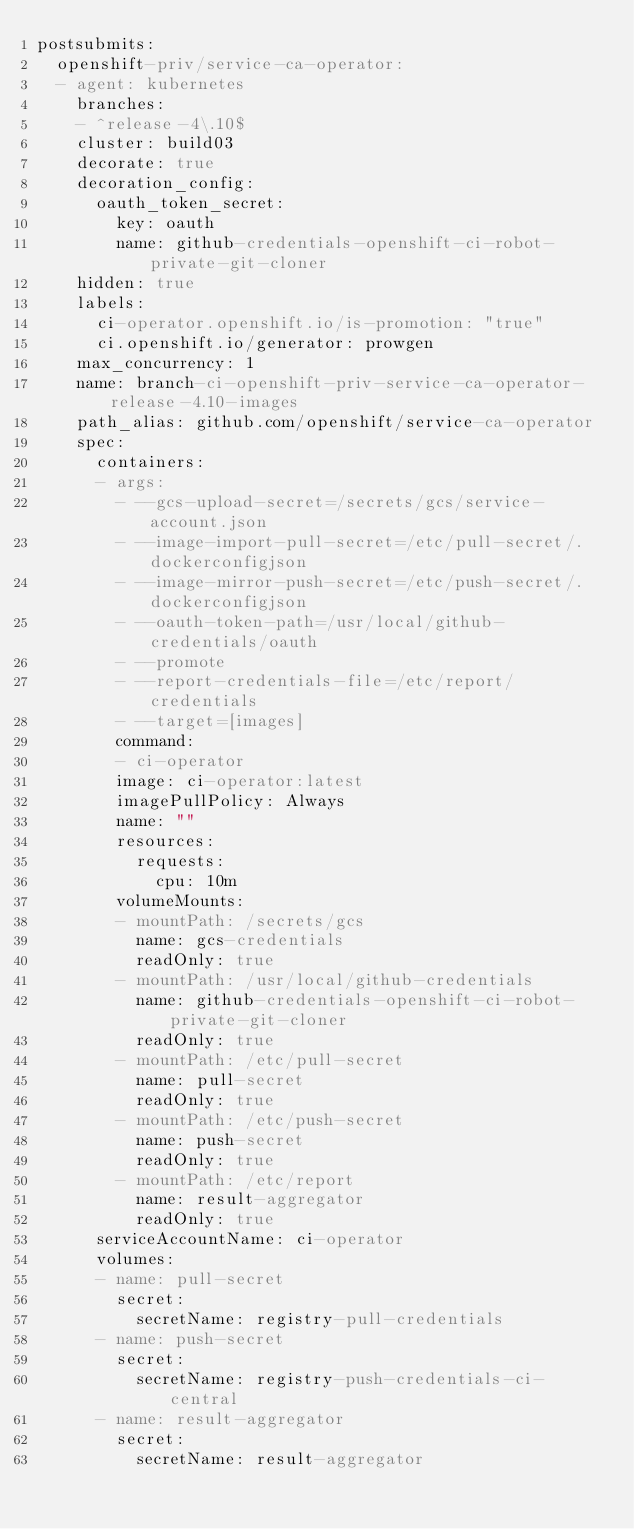Convert code to text. <code><loc_0><loc_0><loc_500><loc_500><_YAML_>postsubmits:
  openshift-priv/service-ca-operator:
  - agent: kubernetes
    branches:
    - ^release-4\.10$
    cluster: build03
    decorate: true
    decoration_config:
      oauth_token_secret:
        key: oauth
        name: github-credentials-openshift-ci-robot-private-git-cloner
    hidden: true
    labels:
      ci-operator.openshift.io/is-promotion: "true"
      ci.openshift.io/generator: prowgen
    max_concurrency: 1
    name: branch-ci-openshift-priv-service-ca-operator-release-4.10-images
    path_alias: github.com/openshift/service-ca-operator
    spec:
      containers:
      - args:
        - --gcs-upload-secret=/secrets/gcs/service-account.json
        - --image-import-pull-secret=/etc/pull-secret/.dockerconfigjson
        - --image-mirror-push-secret=/etc/push-secret/.dockerconfigjson
        - --oauth-token-path=/usr/local/github-credentials/oauth
        - --promote
        - --report-credentials-file=/etc/report/credentials
        - --target=[images]
        command:
        - ci-operator
        image: ci-operator:latest
        imagePullPolicy: Always
        name: ""
        resources:
          requests:
            cpu: 10m
        volumeMounts:
        - mountPath: /secrets/gcs
          name: gcs-credentials
          readOnly: true
        - mountPath: /usr/local/github-credentials
          name: github-credentials-openshift-ci-robot-private-git-cloner
          readOnly: true
        - mountPath: /etc/pull-secret
          name: pull-secret
          readOnly: true
        - mountPath: /etc/push-secret
          name: push-secret
          readOnly: true
        - mountPath: /etc/report
          name: result-aggregator
          readOnly: true
      serviceAccountName: ci-operator
      volumes:
      - name: pull-secret
        secret:
          secretName: registry-pull-credentials
      - name: push-secret
        secret:
          secretName: registry-push-credentials-ci-central
      - name: result-aggregator
        secret:
          secretName: result-aggregator
</code> 